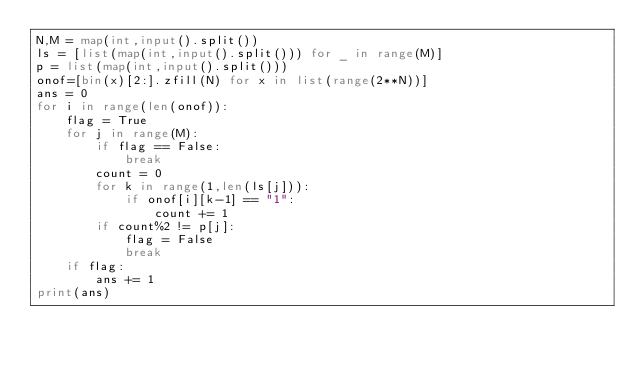<code> <loc_0><loc_0><loc_500><loc_500><_Python_>N,M = map(int,input().split())
ls = [list(map(int,input().split())) for _ in range(M)]
p = list(map(int,input().split()))
onof=[bin(x)[2:].zfill(N) for x in list(range(2**N))]
ans = 0
for i in range(len(onof)):
    flag = True
    for j in range(M):
        if flag == False:
            break
        count = 0
        for k in range(1,len(ls[j])):
            if onof[i][k-1] == "1":
                count += 1
        if count%2 != p[j]:
            flag = False
            break
    if flag:
        ans += 1
print(ans)</code> 